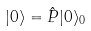Convert formula to latex. <formula><loc_0><loc_0><loc_500><loc_500>| 0 \rangle = \hat { P } | 0 \rangle _ { 0 }</formula> 